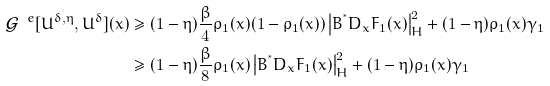<formula> <loc_0><loc_0><loc_500><loc_500>\mathcal { G } ^ { \ e } [ U ^ { \delta , \eta } , U ^ { \delta } ] ( x ) & \geq ( 1 - \eta ) \frac { \beta } { 4 } \rho _ { 1 } ( x ) ( 1 - \rho _ { 1 } ( x ) ) \left | B ^ { ^ { * } } D _ { x } F _ { 1 } ( x ) \right | ^ { 2 } _ { H } + ( 1 - \eta ) \rho _ { 1 } ( x ) \gamma _ { 1 } \\ & \geq ( 1 - \eta ) \frac { \beta } { 8 } \rho _ { 1 } ( x ) \left | B ^ { ^ { * } } D _ { x } F _ { 1 } ( x ) \right | ^ { 2 } _ { H } + ( 1 - \eta ) \rho _ { 1 } ( x ) \gamma _ { 1 }</formula> 